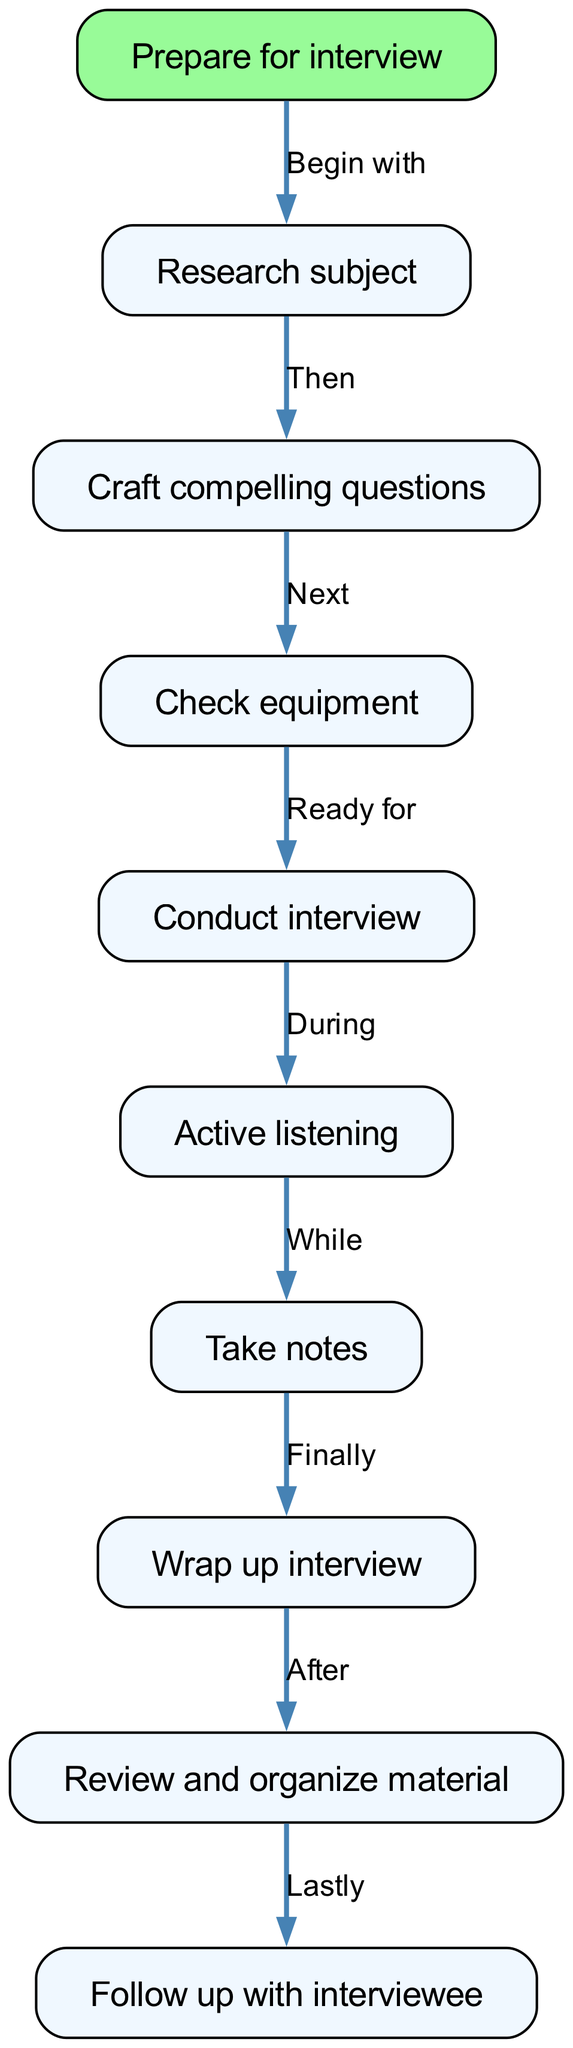What is the first node in the diagram? The first node is labeled "Prepare for interview," which is indicated as the starting point of the flow chart.
Answer: Prepare for interview How many nodes are present in the diagram? By counting all the listed nodes in the flow chart, including the starting node, there are a total of ten nodes.
Answer: 10 Which node comes after "Take notes"? According to the flow of the diagram, "Wrap up interview" is the node that follows "Take notes."
Answer: Wrap up interview What is the label on the edge from "Check equipment" to "Conduct interview"? The edge label describes the relationship, stating "Ready for," indicating that the check of equipment must be completed before conducting the interview.
Answer: Ready for What are the last two nodes in the flow? The final sequence of nodes before concluding the process are "Review and organize material" followed by "Follow up with interviewee."
Answer: Review and organize material, Follow up with interviewee Which node is connected to "Conduct interview" during the interview process? "Active listening" is the node that is directly connected to "Conduct interview," indicating that active listening occurs during the interview.
Answer: Active listening How do you move from "Wrap up interview" to "Follow up with interviewee"? The direction moves from "Wrap up interview" to "Review and organize material" first, and then from there to "Follow up with interviewee," meaning it is a sequential process.
Answer: Review and organize material What does the label indicate from "Research subject" to "Craft compelling questions"? The label "Then" signifies that crafting questions should occur after researching the subject, showing a clear stepwise flow of the interview preparation process.
Answer: Then Which node is highlighted in the diagram as the starting point? The node labeled "Prepare for interview" is the highlighted starting point in the flow chart, distinguishing it from other nodes.
Answer: Prepare for interview 